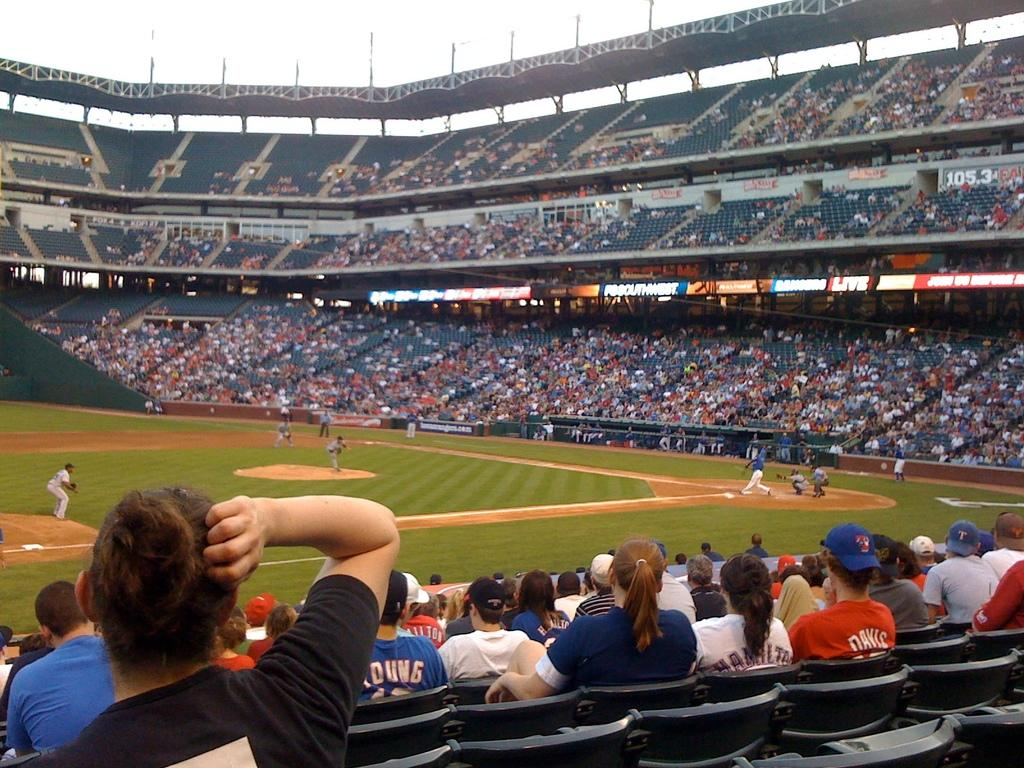What type of structure is the main subject of the image? There is a stadium in the image. What are the people in the image doing? Some people are sitting on chairs, while others are playing in the ground. Are there any signs or notices visible in the image? Yes, there are boards with text in the image. What additional structure can be seen in the image? There is a shed in the image. Can you see a robin perched on the stadium in the image? There is no robin visible in the image; it features a stadium, people, chairs, boards with text, and a shed. 